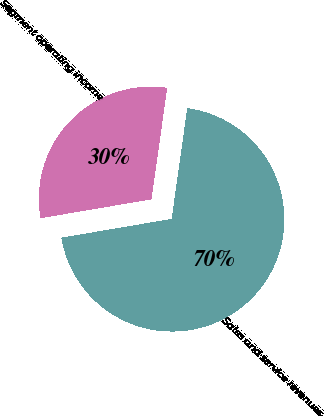<chart> <loc_0><loc_0><loc_500><loc_500><pie_chart><fcel>Sales and service revenues<fcel>Segment operating income<nl><fcel>70.09%<fcel>29.91%<nl></chart> 